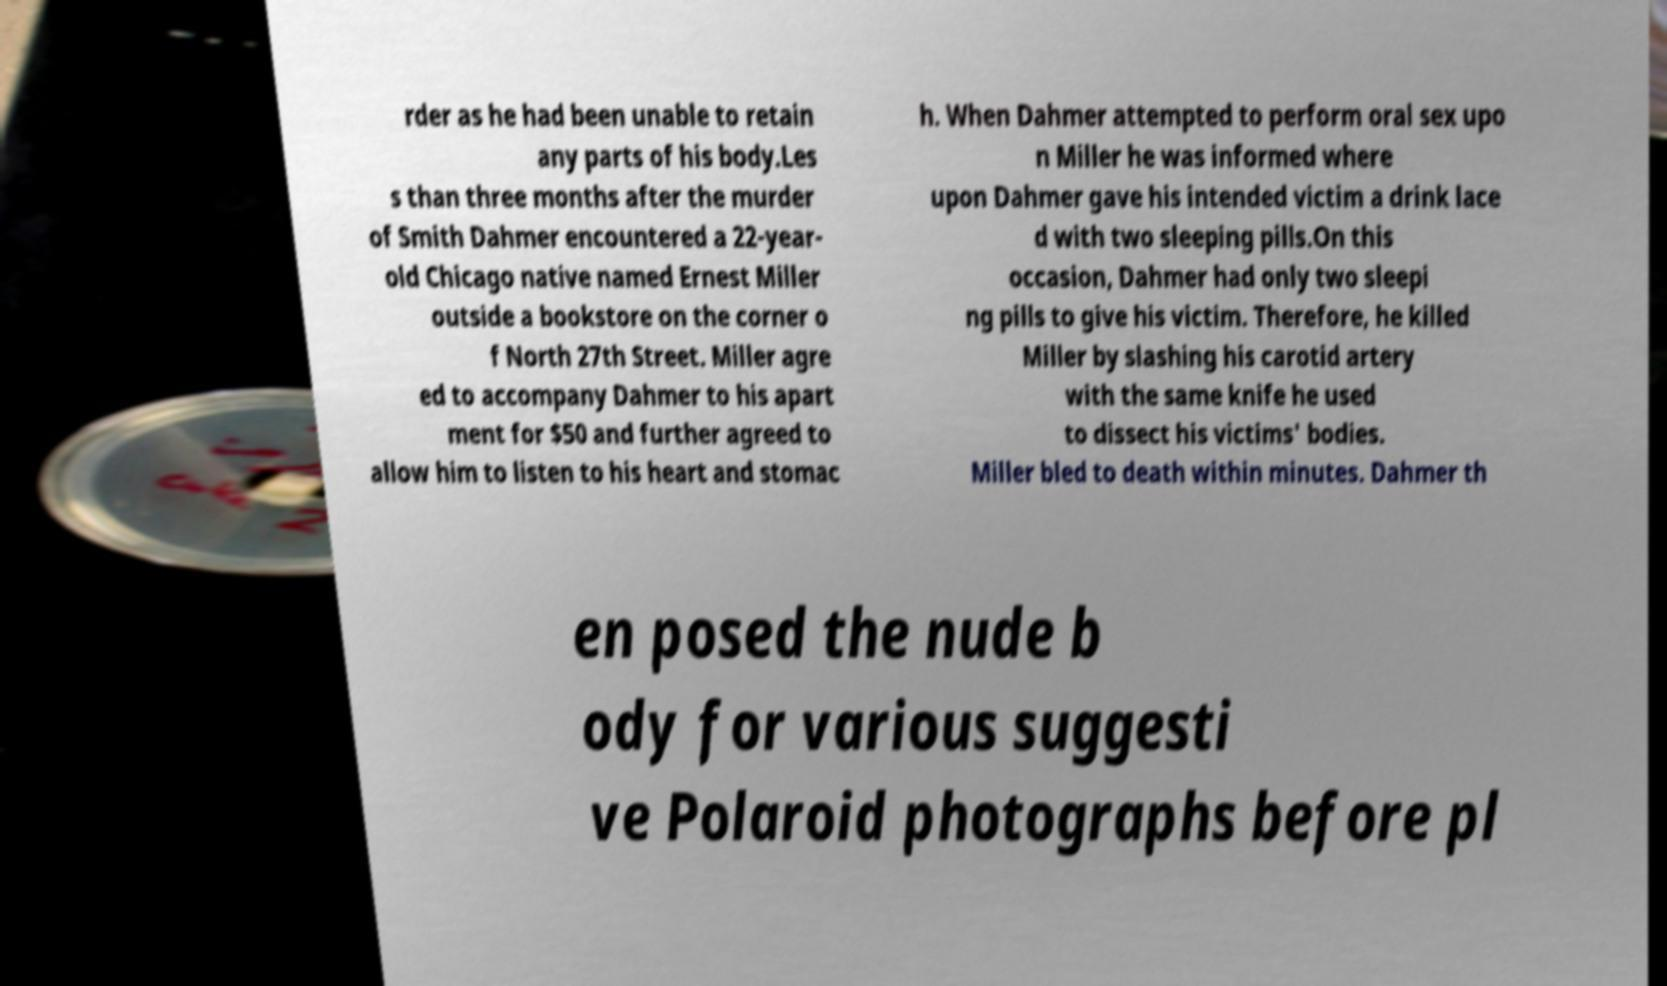For documentation purposes, I need the text within this image transcribed. Could you provide that? rder as he had been unable to retain any parts of his body.Les s than three months after the murder of Smith Dahmer encountered a 22-year- old Chicago native named Ernest Miller outside a bookstore on the corner o f North 27th Street. Miller agre ed to accompany Dahmer to his apart ment for $50 and further agreed to allow him to listen to his heart and stomac h. When Dahmer attempted to perform oral sex upo n Miller he was informed where upon Dahmer gave his intended victim a drink lace d with two sleeping pills.On this occasion, Dahmer had only two sleepi ng pills to give his victim. Therefore, he killed Miller by slashing his carotid artery with the same knife he used to dissect his victims' bodies. Miller bled to death within minutes. Dahmer th en posed the nude b ody for various suggesti ve Polaroid photographs before pl 